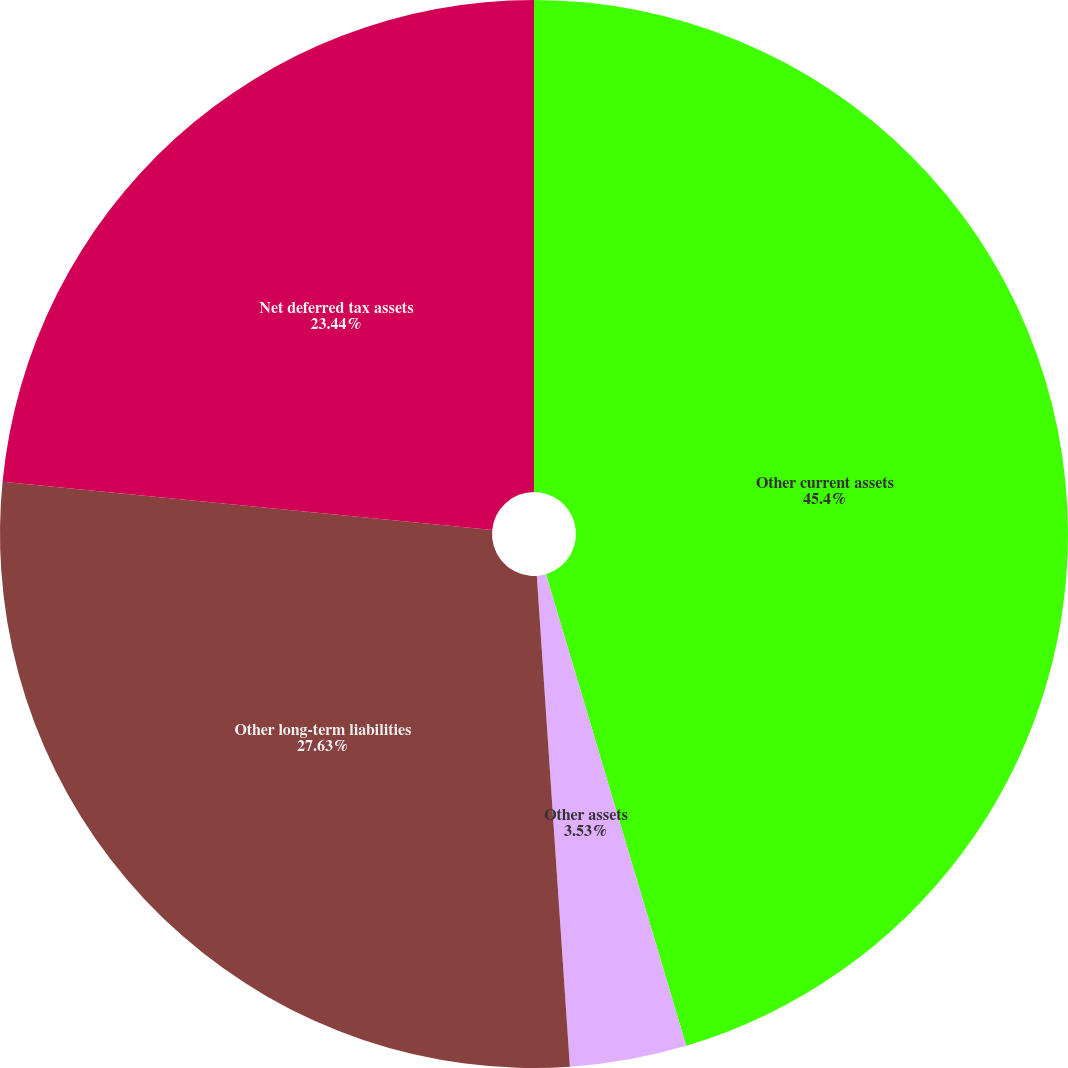<chart> <loc_0><loc_0><loc_500><loc_500><pie_chart><fcel>Other current assets<fcel>Other assets<fcel>Other long-term liabilities<fcel>Net deferred tax assets<nl><fcel>45.4%<fcel>3.53%<fcel>27.63%<fcel>23.44%<nl></chart> 